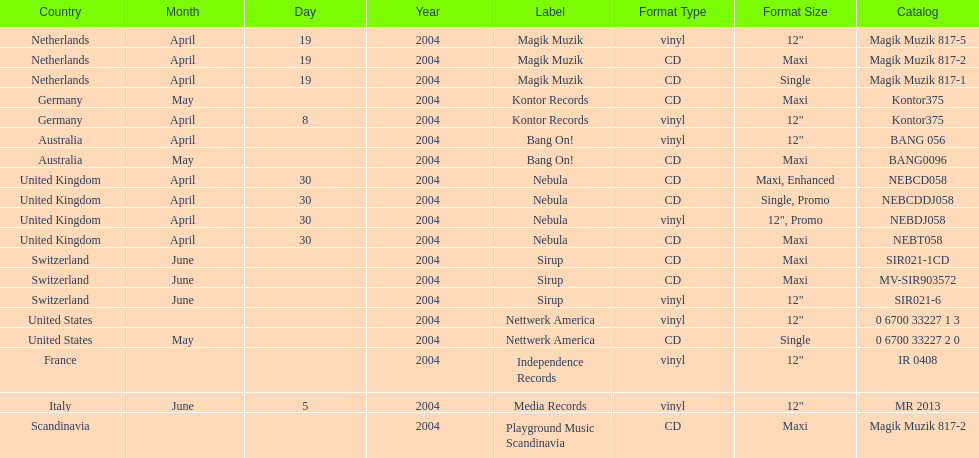Could you parse the entire table? {'header': ['Country', 'Month', 'Day', 'Year', 'Label', 'Format Type', 'Format Size', 'Catalog'], 'rows': [['Netherlands', 'April', '19', '2004', 'Magik Muzik', 'vinyl', '12"', 'Magik Muzik 817-5'], ['Netherlands', 'April', '19', '2004', 'Magik Muzik', 'CD', 'Maxi', 'Magik Muzik 817-2'], ['Netherlands', 'April', '19', '2004', 'Magik Muzik', 'CD', 'Single', 'Magik Muzik 817-1'], ['Germany', 'May', '', '2004', 'Kontor Records', 'CD', 'Maxi', 'Kontor375'], ['Germany', 'April', '8', '2004', 'Kontor Records', 'vinyl', '12"', 'Kontor375'], ['Australia', 'April', '', '2004', 'Bang On!', 'vinyl', '12"', 'BANG 056'], ['Australia', 'May', '', '2004', 'Bang On!', 'CD', 'Maxi', 'BANG0096'], ['United Kingdom', 'April', '30', '2004', 'Nebula', 'CD', 'Maxi, Enhanced', 'NEBCD058'], ['United Kingdom', 'April', '30', '2004', 'Nebula', 'CD', 'Single, Promo', 'NEBCDDJ058'], ['United Kingdom', 'April', '30', '2004', 'Nebula', 'vinyl', '12", Promo', 'NEBDJ058'], ['United Kingdom', 'April', '30', '2004', 'Nebula', 'CD', 'Maxi', 'NEBT058'], ['Switzerland', 'June', '', '2004', 'Sirup', 'CD', 'Maxi', 'SIR021-1CD'], ['Switzerland', 'June', '', '2004', 'Sirup', 'CD', 'Maxi', 'MV-SIR903572'], ['Switzerland', 'June', '', '2004', 'Sirup', 'vinyl', '12"', 'SIR021-6'], ['United States', '', '', '2004', 'Nettwerk America', 'vinyl', '12"', '0 6700 33227 1 3'], ['United States', 'May', '', '2004', 'Nettwerk America', 'CD', 'Single', '0 6700 33227 2 0'], ['France', '', '', '2004', 'Independence Records', 'vinyl', '12"', 'IR 0408'], ['Italy', 'June', '5', '2004', 'Media Records', 'vinyl', '12"', 'MR 2013'], ['Scandinavia', '', '', '2004', 'Playground Music Scandinavia', 'CD', 'Maxi', 'Magik Muzik 817-2']]} What label was the only label to be used by france? Independence Records. 